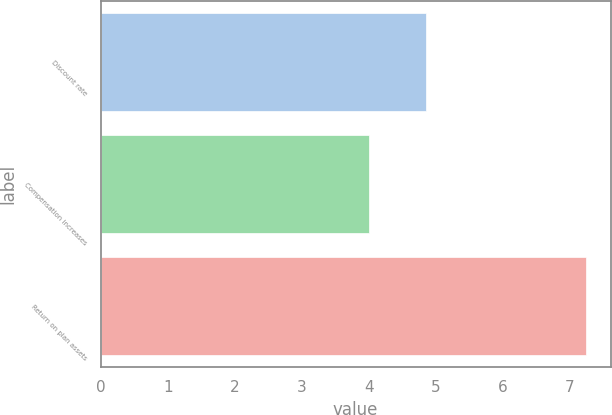<chart> <loc_0><loc_0><loc_500><loc_500><bar_chart><fcel>Discount rate<fcel>Compensation increases<fcel>Return on plan assets<nl><fcel>4.85<fcel>4<fcel>7.25<nl></chart> 